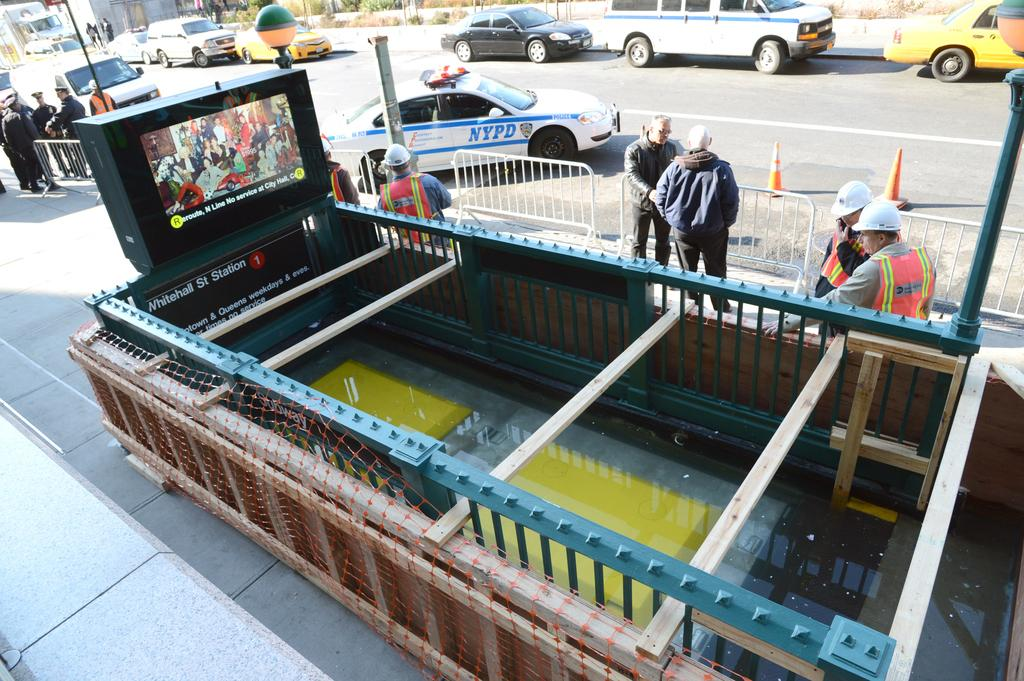<image>
Describe the image concisely. an NYPD car that is on the street 